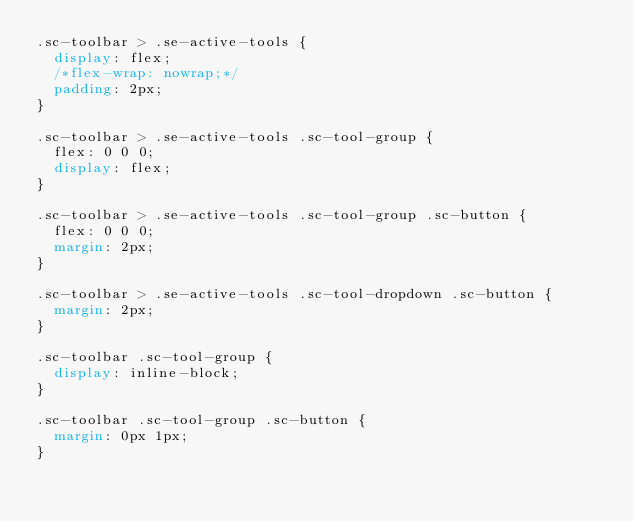<code> <loc_0><loc_0><loc_500><loc_500><_CSS_>.sc-toolbar > .se-active-tools {
  display: flex;
  /*flex-wrap: nowrap;*/
  padding: 2px;
}

.sc-toolbar > .se-active-tools .sc-tool-group {
  flex: 0 0 0;
  display: flex;
}

.sc-toolbar > .se-active-tools .sc-tool-group .sc-button {
  flex: 0 0 0;
  margin: 2px;
}

.sc-toolbar > .se-active-tools .sc-tool-dropdown .sc-button {
  margin: 2px;
}

.sc-toolbar .sc-tool-group {
  display: inline-block;
}

.sc-toolbar .sc-tool-group .sc-button {
  margin: 0px 1px;
}
</code> 